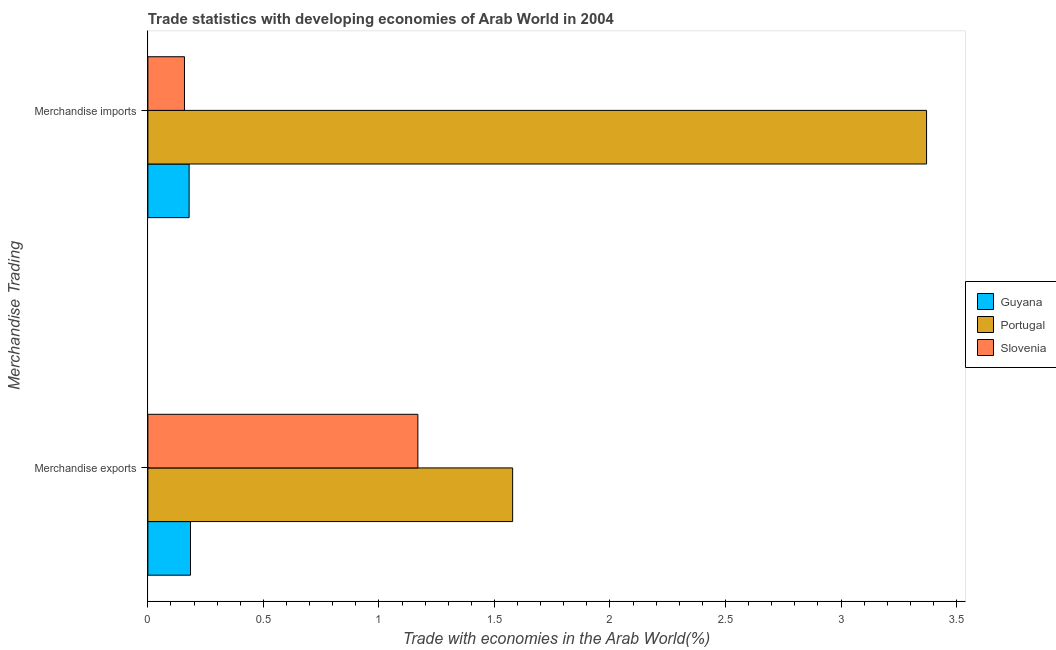How many different coloured bars are there?
Your answer should be compact. 3. How many groups of bars are there?
Your answer should be compact. 2. Are the number of bars on each tick of the Y-axis equal?
Ensure brevity in your answer.  Yes. How many bars are there on the 1st tick from the top?
Make the answer very short. 3. What is the merchandise exports in Portugal?
Ensure brevity in your answer.  1.58. Across all countries, what is the maximum merchandise exports?
Provide a succinct answer. 1.58. Across all countries, what is the minimum merchandise imports?
Your response must be concise. 0.16. In which country was the merchandise exports minimum?
Provide a short and direct response. Guyana. What is the total merchandise imports in the graph?
Your response must be concise. 3.71. What is the difference between the merchandise imports in Portugal and that in Slovenia?
Your answer should be compact. 3.21. What is the difference between the merchandise imports in Guyana and the merchandise exports in Portugal?
Your answer should be compact. -1.4. What is the average merchandise imports per country?
Offer a terse response. 1.24. What is the difference between the merchandise exports and merchandise imports in Portugal?
Provide a short and direct response. -1.79. What is the ratio of the merchandise exports in Slovenia to that in Guyana?
Make the answer very short. 6.33. What does the 3rd bar from the bottom in Merchandise exports represents?
Ensure brevity in your answer.  Slovenia. How many bars are there?
Provide a short and direct response. 6. What is the difference between two consecutive major ticks on the X-axis?
Offer a very short reply. 0.5. How many legend labels are there?
Offer a very short reply. 3. What is the title of the graph?
Provide a succinct answer. Trade statistics with developing economies of Arab World in 2004. What is the label or title of the X-axis?
Your answer should be very brief. Trade with economies in the Arab World(%). What is the label or title of the Y-axis?
Make the answer very short. Merchandise Trading. What is the Trade with economies in the Arab World(%) in Guyana in Merchandise exports?
Offer a terse response. 0.18. What is the Trade with economies in the Arab World(%) in Portugal in Merchandise exports?
Give a very brief answer. 1.58. What is the Trade with economies in the Arab World(%) in Slovenia in Merchandise exports?
Your answer should be compact. 1.17. What is the Trade with economies in the Arab World(%) in Guyana in Merchandise imports?
Ensure brevity in your answer.  0.18. What is the Trade with economies in the Arab World(%) of Portugal in Merchandise imports?
Your answer should be very brief. 3.37. What is the Trade with economies in the Arab World(%) in Slovenia in Merchandise imports?
Ensure brevity in your answer.  0.16. Across all Merchandise Trading, what is the maximum Trade with economies in the Arab World(%) in Guyana?
Your answer should be very brief. 0.18. Across all Merchandise Trading, what is the maximum Trade with economies in the Arab World(%) of Portugal?
Your response must be concise. 3.37. Across all Merchandise Trading, what is the maximum Trade with economies in the Arab World(%) of Slovenia?
Offer a very short reply. 1.17. Across all Merchandise Trading, what is the minimum Trade with economies in the Arab World(%) in Guyana?
Your answer should be very brief. 0.18. Across all Merchandise Trading, what is the minimum Trade with economies in the Arab World(%) in Portugal?
Make the answer very short. 1.58. Across all Merchandise Trading, what is the minimum Trade with economies in the Arab World(%) of Slovenia?
Offer a terse response. 0.16. What is the total Trade with economies in the Arab World(%) of Guyana in the graph?
Offer a very short reply. 0.36. What is the total Trade with economies in the Arab World(%) of Portugal in the graph?
Offer a very short reply. 4.95. What is the total Trade with economies in the Arab World(%) in Slovenia in the graph?
Give a very brief answer. 1.33. What is the difference between the Trade with economies in the Arab World(%) of Guyana in Merchandise exports and that in Merchandise imports?
Your answer should be very brief. 0.01. What is the difference between the Trade with economies in the Arab World(%) in Portugal in Merchandise exports and that in Merchandise imports?
Your response must be concise. -1.79. What is the difference between the Trade with economies in the Arab World(%) in Slovenia in Merchandise exports and that in Merchandise imports?
Give a very brief answer. 1.01. What is the difference between the Trade with economies in the Arab World(%) in Guyana in Merchandise exports and the Trade with economies in the Arab World(%) in Portugal in Merchandise imports?
Keep it short and to the point. -3.19. What is the difference between the Trade with economies in the Arab World(%) of Guyana in Merchandise exports and the Trade with economies in the Arab World(%) of Slovenia in Merchandise imports?
Offer a terse response. 0.03. What is the difference between the Trade with economies in the Arab World(%) of Portugal in Merchandise exports and the Trade with economies in the Arab World(%) of Slovenia in Merchandise imports?
Make the answer very short. 1.42. What is the average Trade with economies in the Arab World(%) in Guyana per Merchandise Trading?
Offer a terse response. 0.18. What is the average Trade with economies in the Arab World(%) in Portugal per Merchandise Trading?
Keep it short and to the point. 2.47. What is the average Trade with economies in the Arab World(%) of Slovenia per Merchandise Trading?
Your response must be concise. 0.66. What is the difference between the Trade with economies in the Arab World(%) of Guyana and Trade with economies in the Arab World(%) of Portugal in Merchandise exports?
Your response must be concise. -1.39. What is the difference between the Trade with economies in the Arab World(%) of Guyana and Trade with economies in the Arab World(%) of Slovenia in Merchandise exports?
Give a very brief answer. -0.98. What is the difference between the Trade with economies in the Arab World(%) in Portugal and Trade with economies in the Arab World(%) in Slovenia in Merchandise exports?
Give a very brief answer. 0.41. What is the difference between the Trade with economies in the Arab World(%) in Guyana and Trade with economies in the Arab World(%) in Portugal in Merchandise imports?
Your answer should be compact. -3.19. What is the difference between the Trade with economies in the Arab World(%) in Guyana and Trade with economies in the Arab World(%) in Slovenia in Merchandise imports?
Give a very brief answer. 0.02. What is the difference between the Trade with economies in the Arab World(%) of Portugal and Trade with economies in the Arab World(%) of Slovenia in Merchandise imports?
Give a very brief answer. 3.21. What is the ratio of the Trade with economies in the Arab World(%) of Portugal in Merchandise exports to that in Merchandise imports?
Your answer should be very brief. 0.47. What is the ratio of the Trade with economies in the Arab World(%) of Slovenia in Merchandise exports to that in Merchandise imports?
Your answer should be compact. 7.38. What is the difference between the highest and the second highest Trade with economies in the Arab World(%) in Guyana?
Provide a short and direct response. 0.01. What is the difference between the highest and the second highest Trade with economies in the Arab World(%) of Portugal?
Give a very brief answer. 1.79. What is the difference between the highest and the second highest Trade with economies in the Arab World(%) of Slovenia?
Your answer should be very brief. 1.01. What is the difference between the highest and the lowest Trade with economies in the Arab World(%) of Guyana?
Provide a succinct answer. 0.01. What is the difference between the highest and the lowest Trade with economies in the Arab World(%) in Portugal?
Make the answer very short. 1.79. What is the difference between the highest and the lowest Trade with economies in the Arab World(%) of Slovenia?
Offer a terse response. 1.01. 